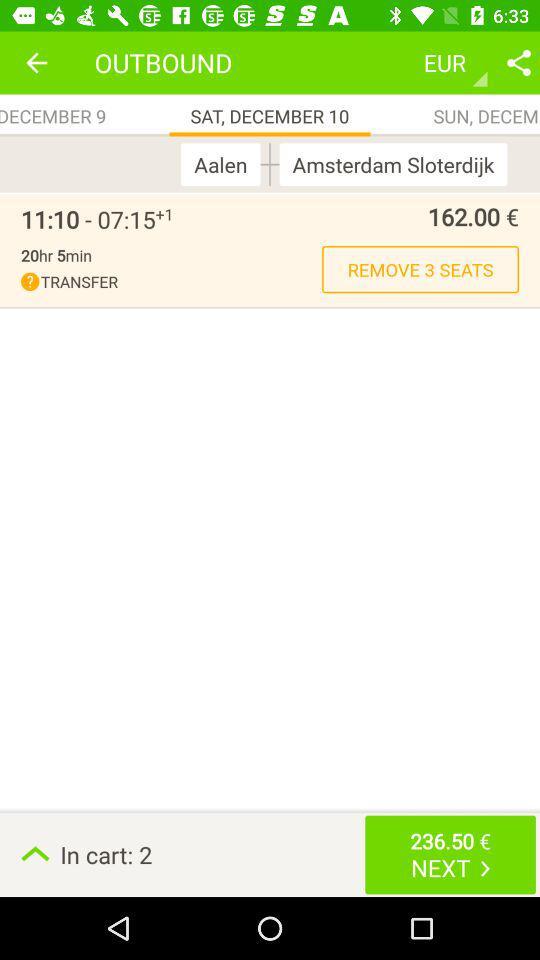How many seats are there in the cart?
Answer the question using a single word or phrase. 2 